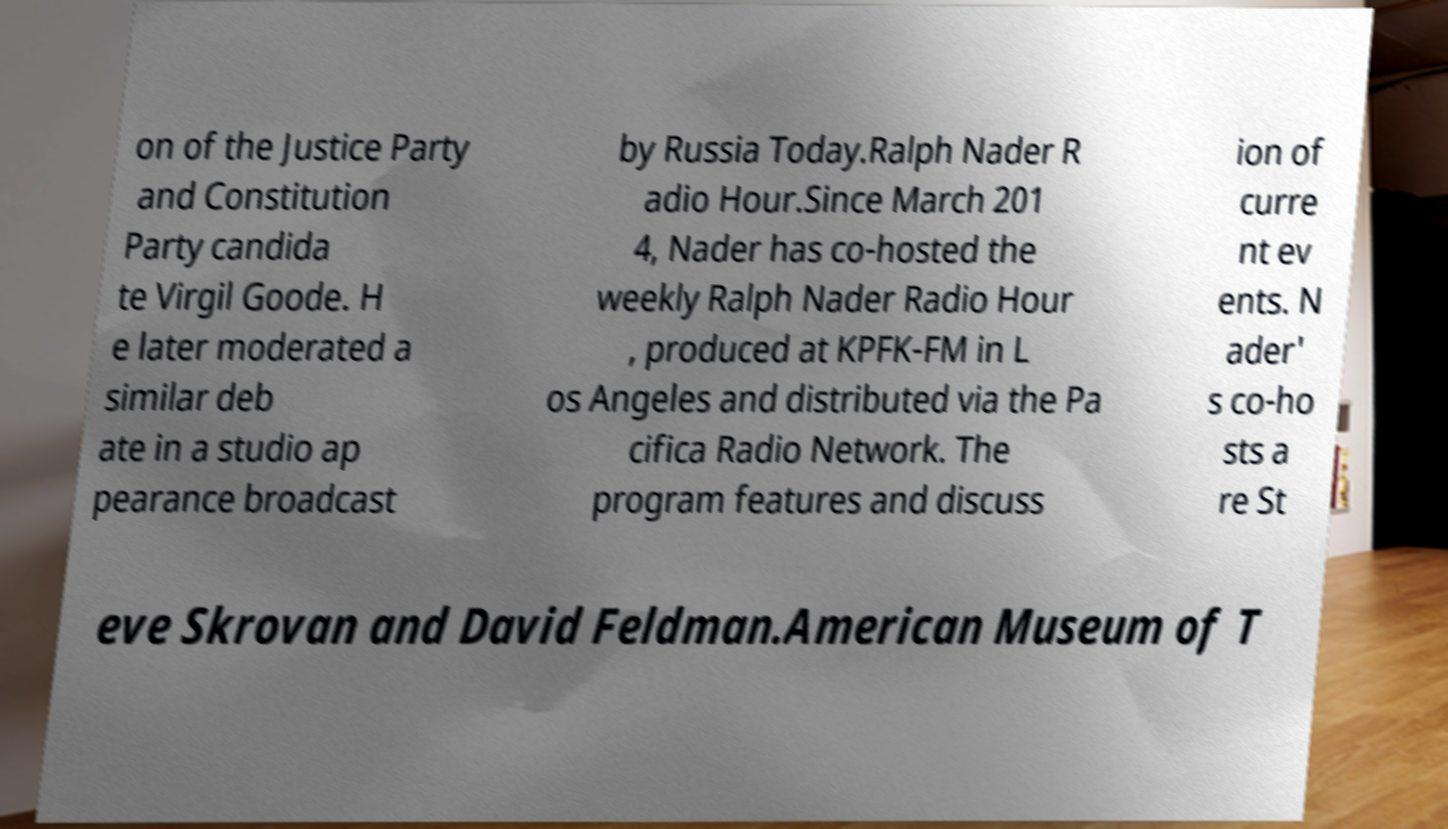There's text embedded in this image that I need extracted. Can you transcribe it verbatim? on of the Justice Party and Constitution Party candida te Virgil Goode. H e later moderated a similar deb ate in a studio ap pearance broadcast by Russia Today.Ralph Nader R adio Hour.Since March 201 4, Nader has co-hosted the weekly Ralph Nader Radio Hour , produced at KPFK-FM in L os Angeles and distributed via the Pa cifica Radio Network. The program features and discuss ion of curre nt ev ents. N ader' s co-ho sts a re St eve Skrovan and David Feldman.American Museum of T 